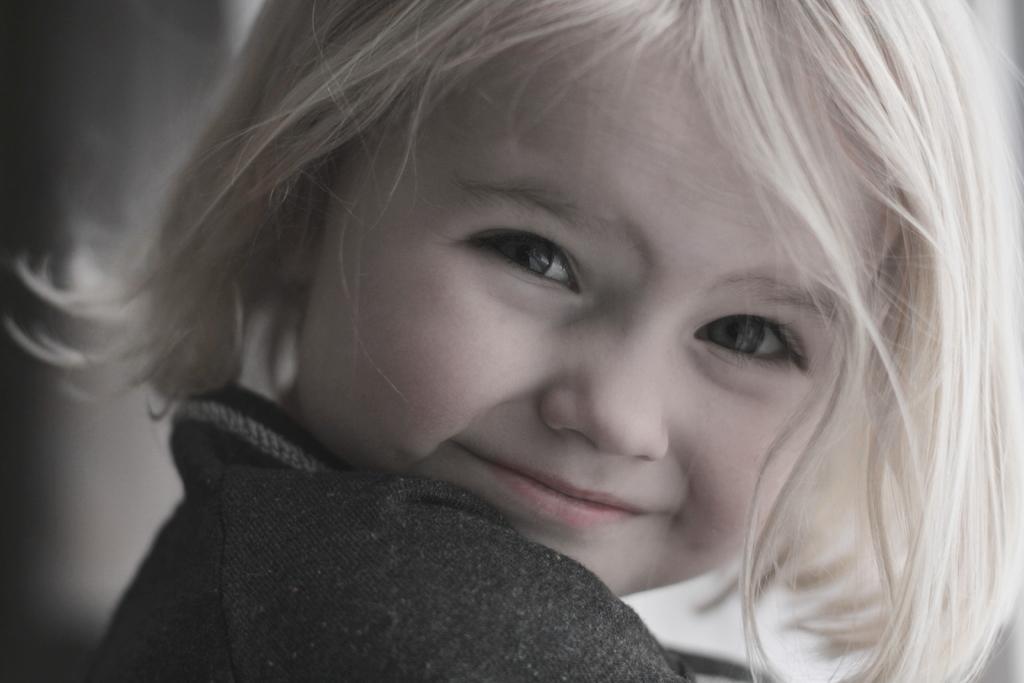How would you summarize this image in a sentence or two? The picture consists of a kid. The background is blurred. 